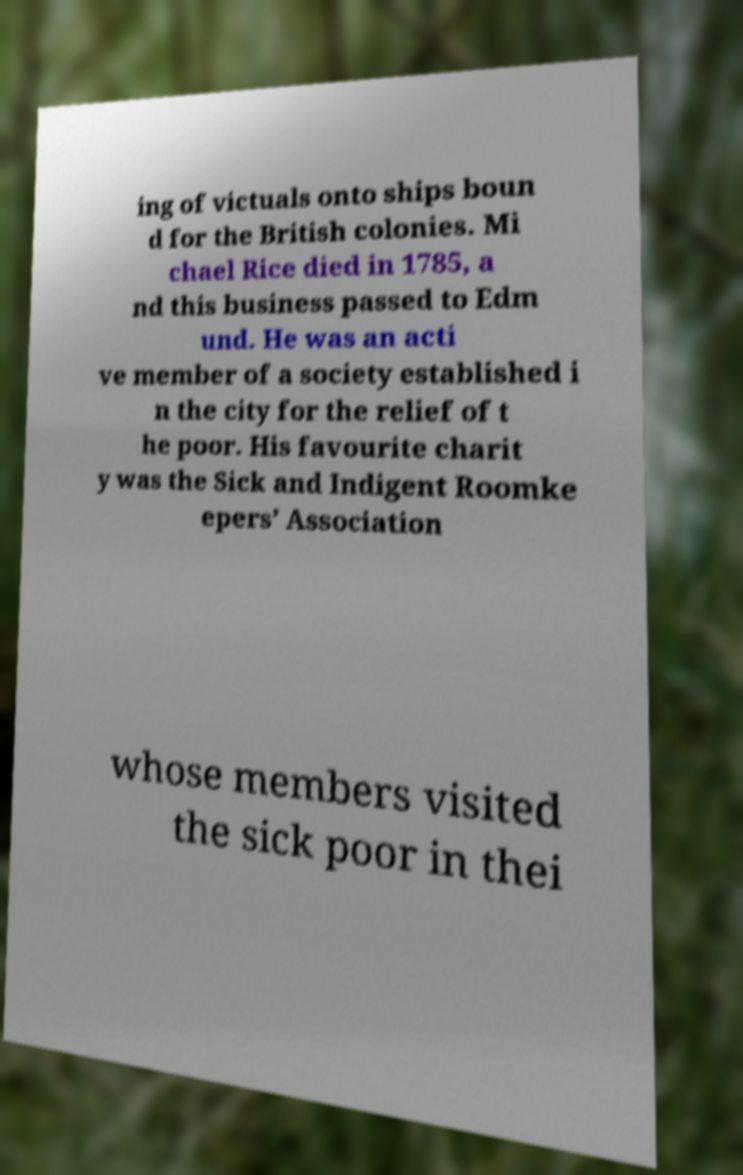Please read and relay the text visible in this image. What does it say? ing of victuals onto ships boun d for the British colonies. Mi chael Rice died in 1785, a nd this business passed to Edm und. He was an acti ve member of a society established i n the city for the relief of t he poor. His favourite charit y was the Sick and Indigent Roomke epers’ Association whose members visited the sick poor in thei 